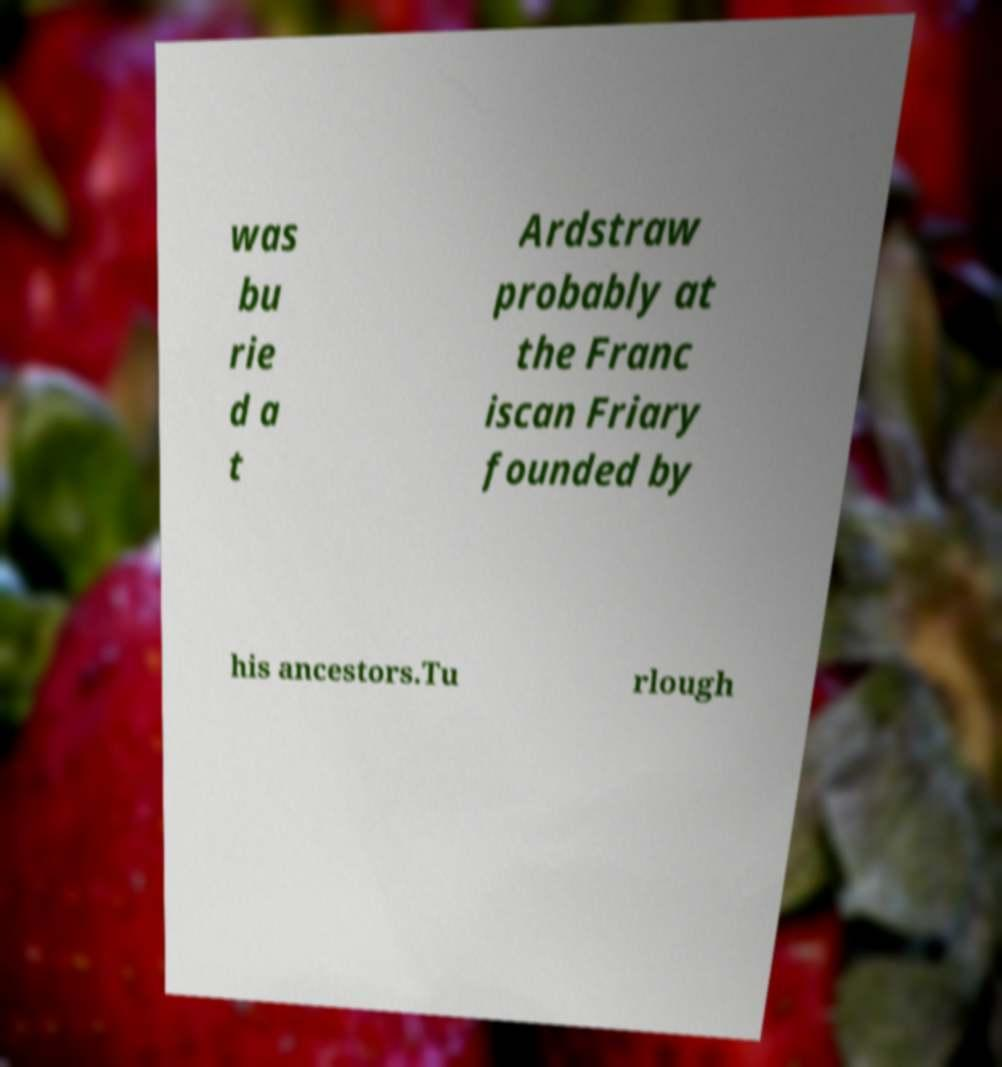Please read and relay the text visible in this image. What does it say? was bu rie d a t Ardstraw probably at the Franc iscan Friary founded by his ancestors.Tu rlough 